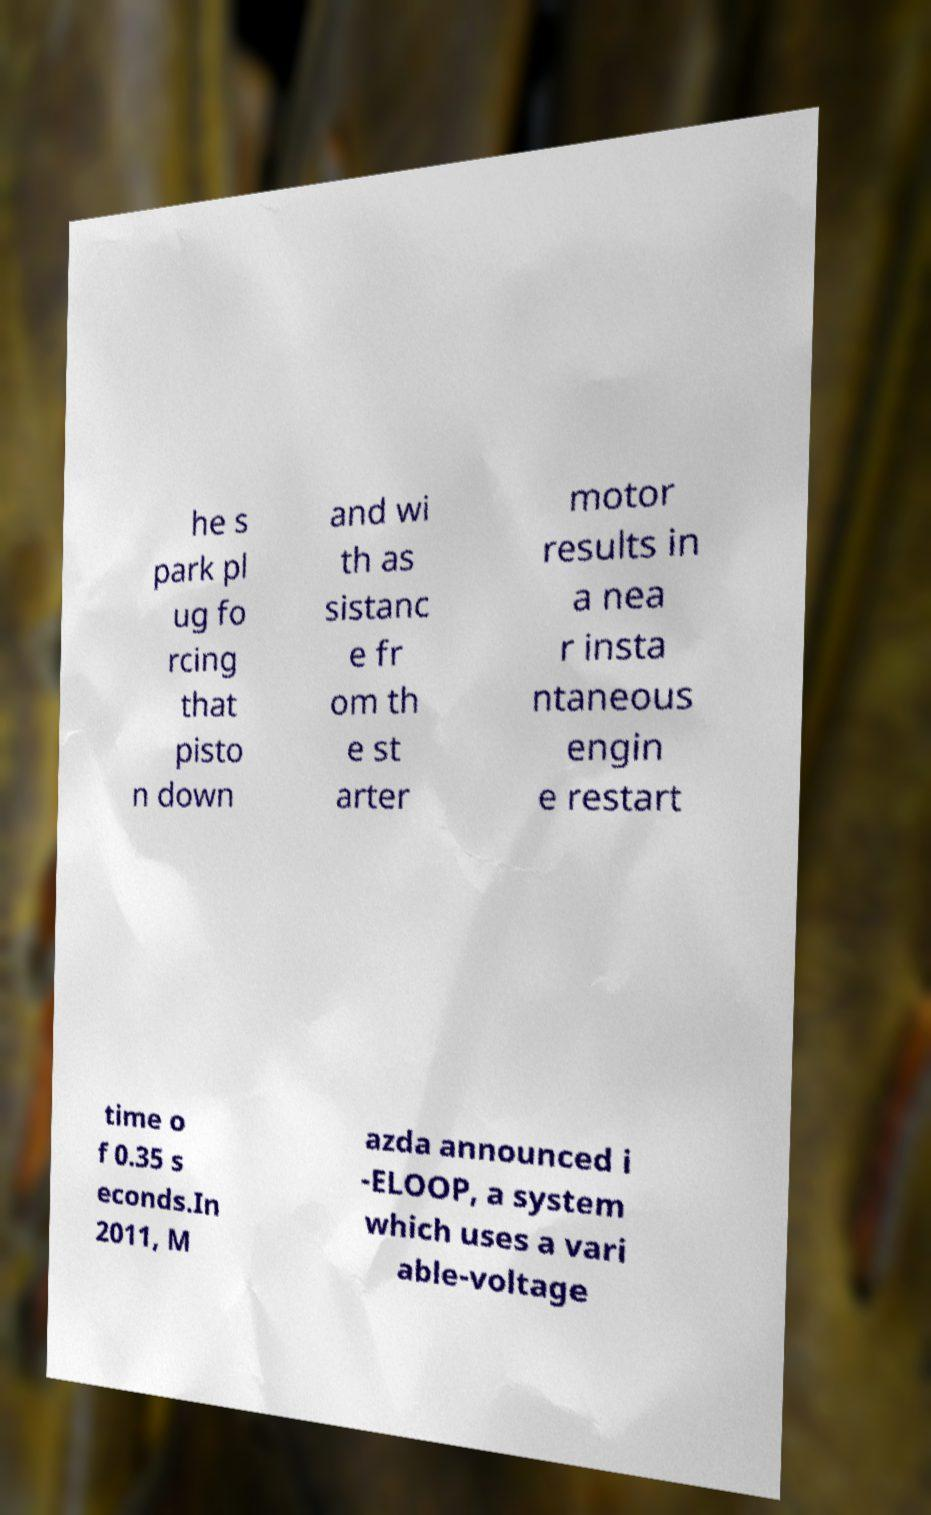Please read and relay the text visible in this image. What does it say? he s park pl ug fo rcing that pisto n down and wi th as sistanc e fr om th e st arter motor results in a nea r insta ntaneous engin e restart time o f 0.35 s econds.In 2011, M azda announced i -ELOOP, a system which uses a vari able-voltage 